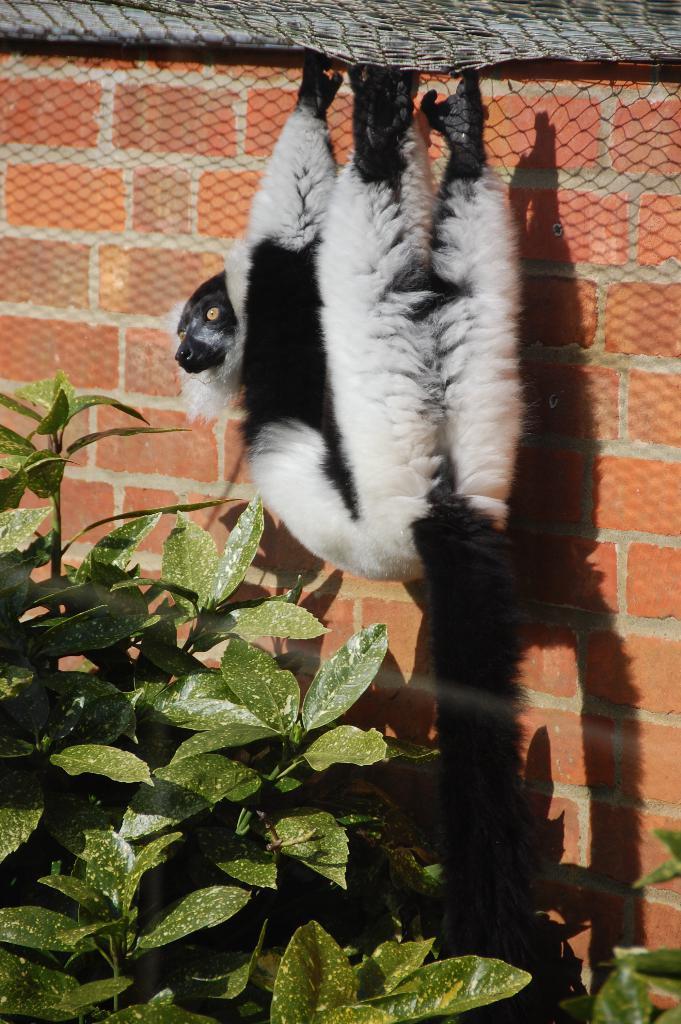Could you give a brief overview of what you see in this image? In the picture we can see a plant near it, we can see a wall with bricks and net to it and a monkey hung to it. 